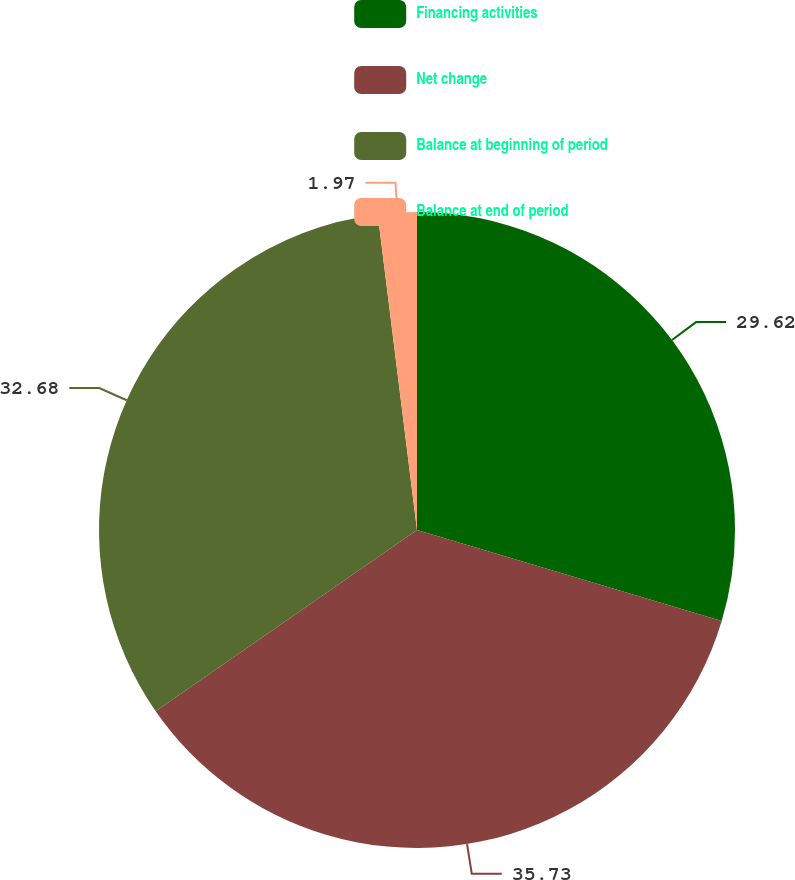<chart> <loc_0><loc_0><loc_500><loc_500><pie_chart><fcel>Financing activities<fcel>Net change<fcel>Balance at beginning of period<fcel>Balance at end of period<nl><fcel>29.62%<fcel>35.73%<fcel>32.68%<fcel>1.97%<nl></chart> 